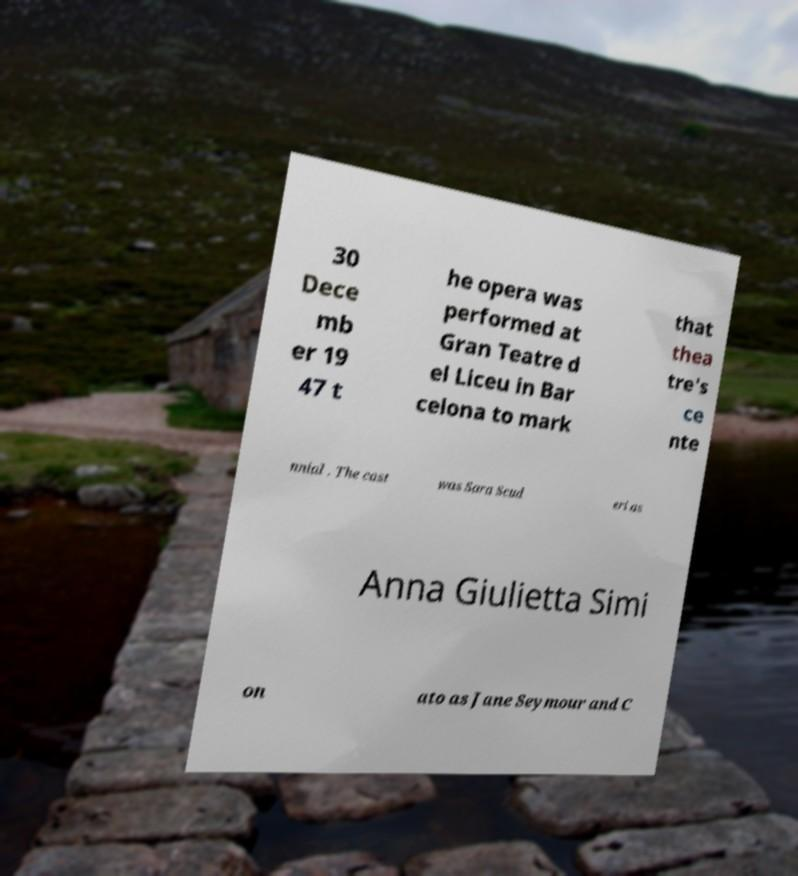I need the written content from this picture converted into text. Can you do that? 30 Dece mb er 19 47 t he opera was performed at Gran Teatre d el Liceu in Bar celona to mark that thea tre's ce nte nnial . The cast was Sara Scud eri as Anna Giulietta Simi on ato as Jane Seymour and C 